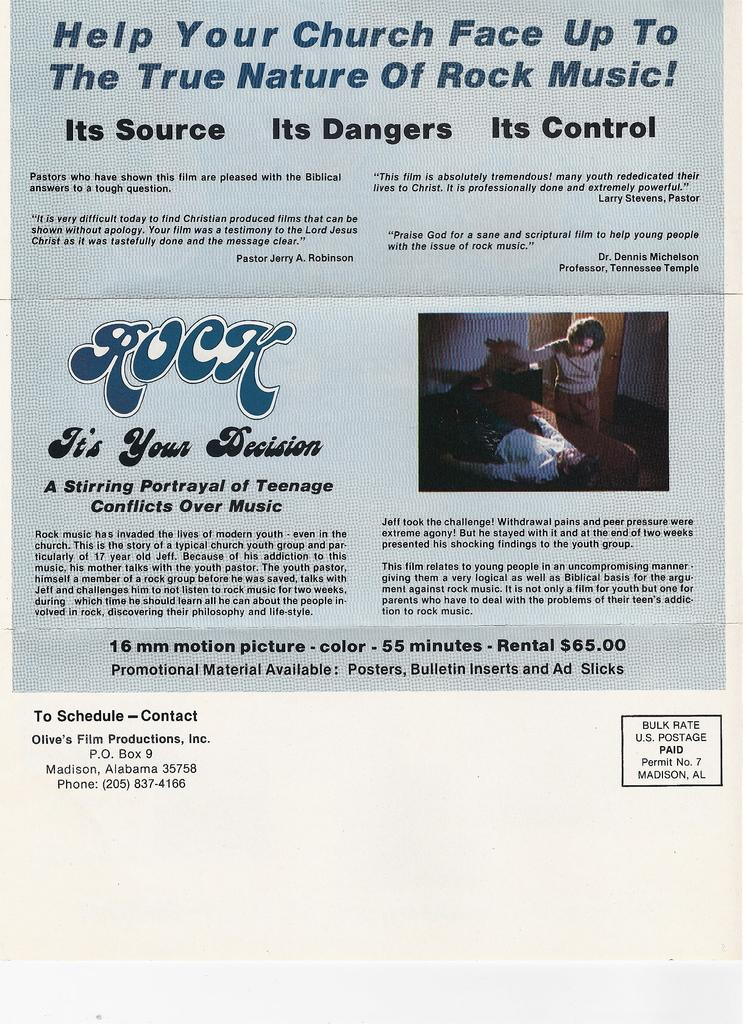What type of publication is visible in the image? There is a magazine in the image. What can be found within the magazine? The magazine contains information. Is there any visual content on the magazine? Yes, there is an image on the magazine. How many hours does the calculator on the magazine display? There is no calculator present in the image, so it is not possible to determine the hour displayed on a calculator. 